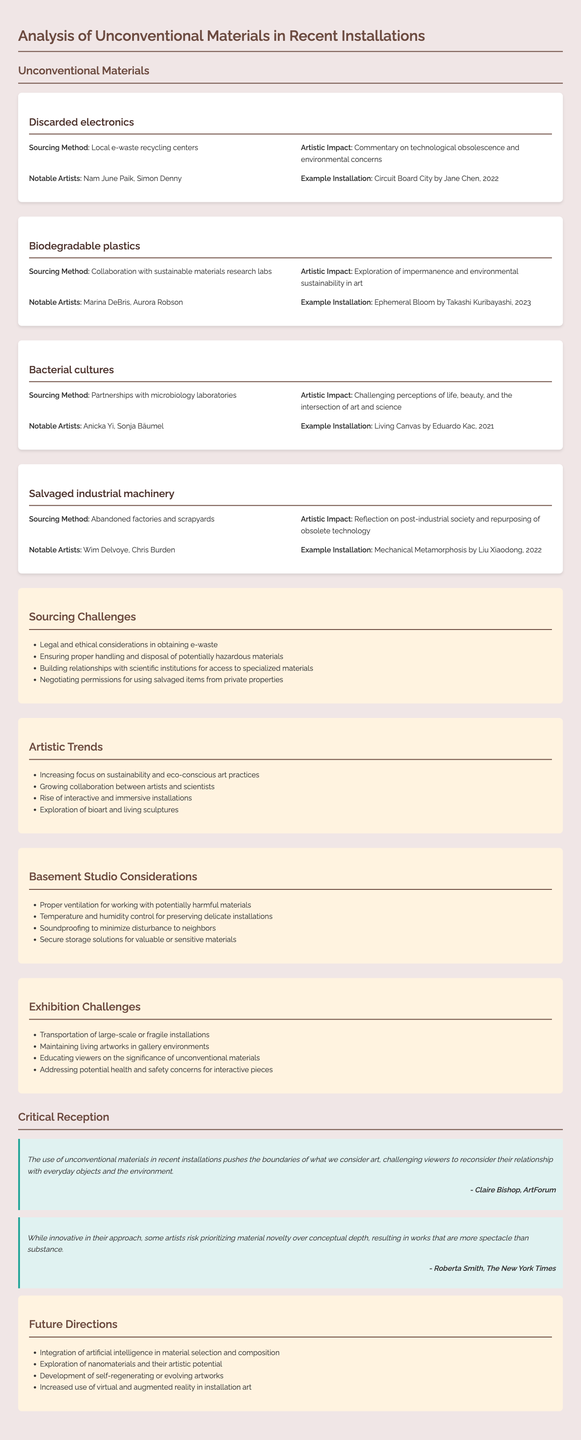What is the material used in "Circuit Board City"? The document states that "Circuit Board City" by Jane Chen uses discarded electronics.
Answer: Discarded electronics Who collaborated with sustainable materials research labs? The document mentions that Takashi Kuribayashi worked with sustainable materials research labs for the installation "Ephemeral Bloom."
Answer: Takashi Kuribayashi What sourcing challenge involves potentially hazardous materials? The document lists "Ensuring proper handling and disposal of potentially hazardous materials" as one of the sourcing challenges.
Answer: Ensuring proper handling and disposal of potentially hazardous materials What is the artistic impact of bacterial cultures? The document explains that the use of bacterial cultures challenges perceptions of life, beauty, and the intersection of art and science.
Answer: Challenging perceptions of life, beauty, and the intersection of art and science Which publication featured a critique by Claire Bishop? According to the document, ArtForum featured a critique by Claire Bishop on unconventional materials in installations.
Answer: ArtForum What trend is noted regarding the collaboration between disciplines? The document mentions "Growing collaboration between artists and scientists" as an artistic trend.
Answer: Growing collaboration between artists and scientists What consideration is important for basement studio environments? The document lists "Proper ventilation for working with potentially harmful materials" as a key consideration for basement studios.
Answer: Proper ventilation for working with potentially harmful materials What type of materials are explored in future directions? The document suggests that future directions involve the exploration of nanomaterials and their artistic potential.
Answer: Nanomaterials What installation was created by Liu Xiaodong? The document states that Liu Xiaodong created the installation "Mechanical Metamorphosis."
Answer: Mechanical Metamorphosis 